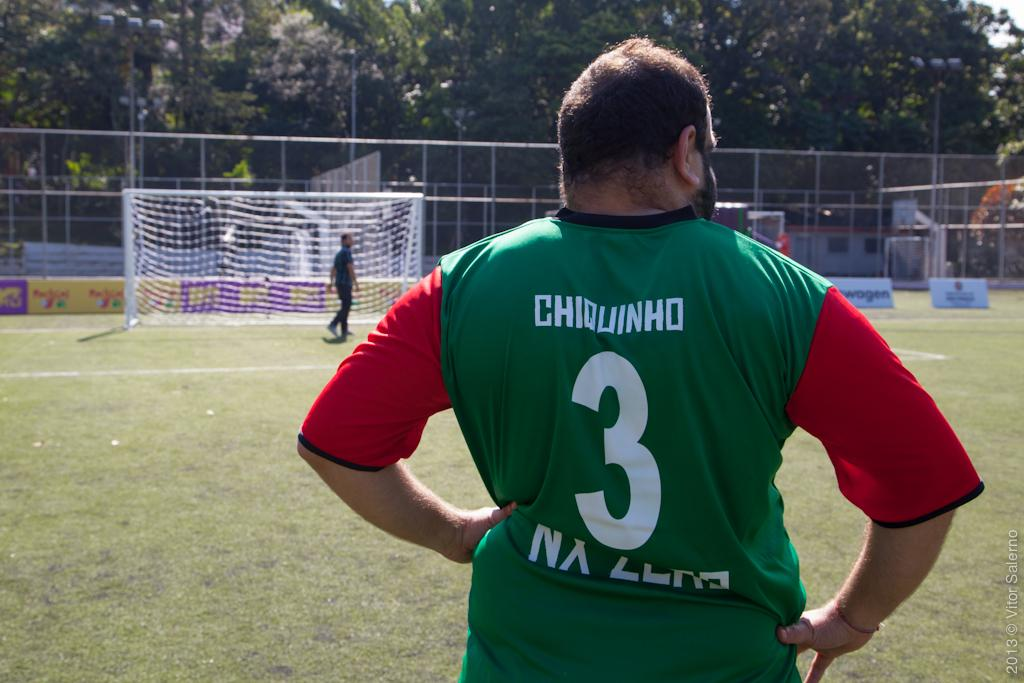Provide a one-sentence caption for the provided image. A soccer player stands on the field his jersey says Chiquinho number 3. 